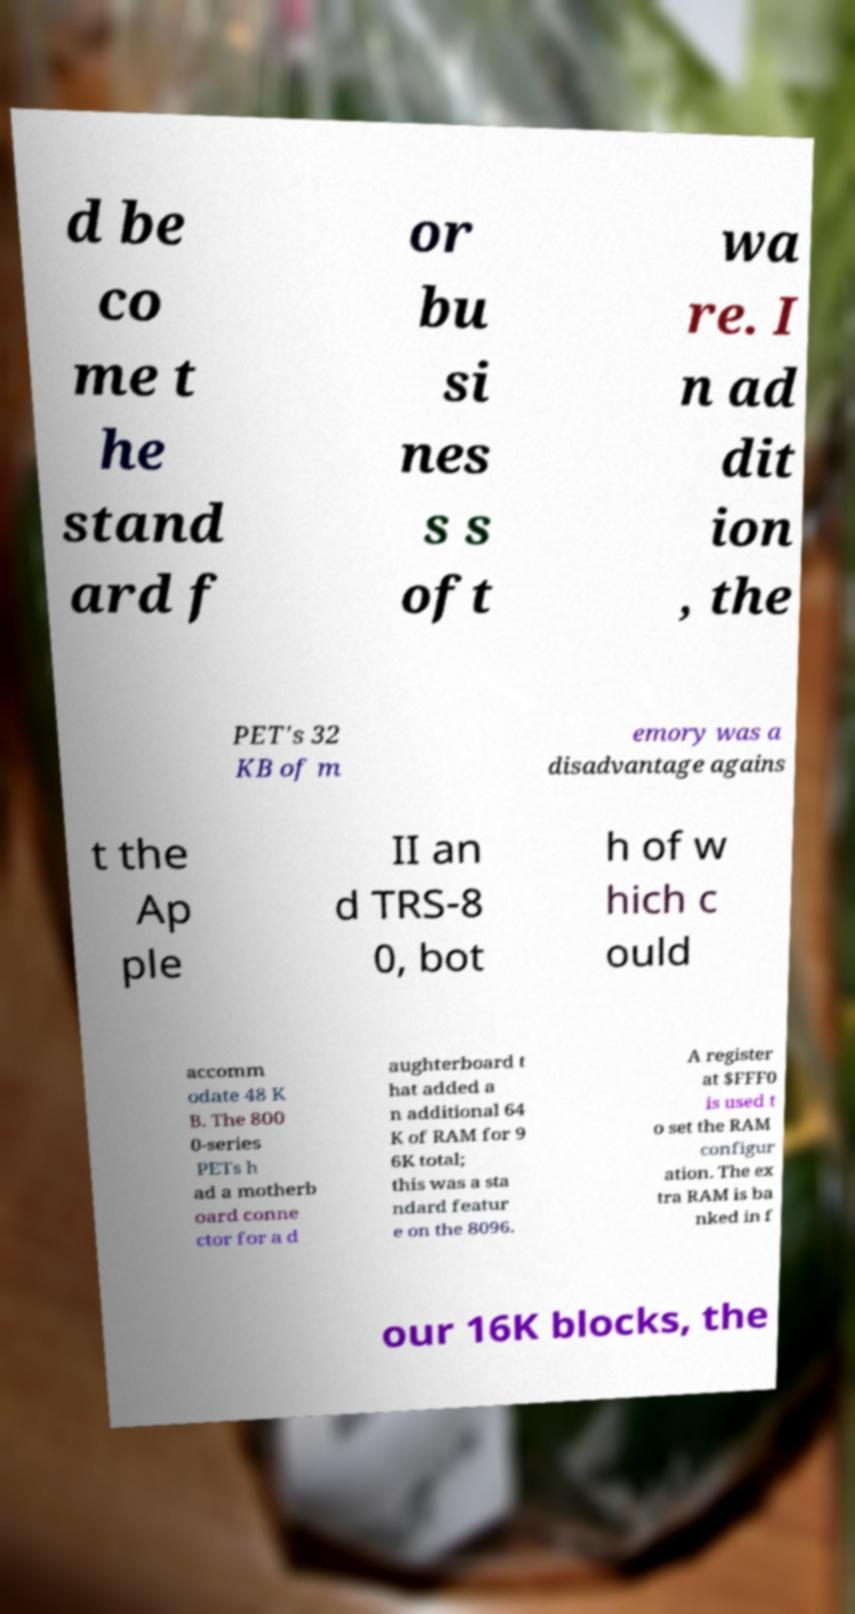Please read and relay the text visible in this image. What does it say? d be co me t he stand ard f or bu si nes s s oft wa re. I n ad dit ion , the PET's 32 KB of m emory was a disadvantage agains t the Ap ple II an d TRS-8 0, bot h of w hich c ould accomm odate 48 K B. The 800 0-series PETs h ad a motherb oard conne ctor for a d aughterboard t hat added a n additional 64 K of RAM for 9 6K total; this was a sta ndard featur e on the 8096. A register at $FFF0 is used t o set the RAM configur ation. The ex tra RAM is ba nked in f our 16K blocks, the 